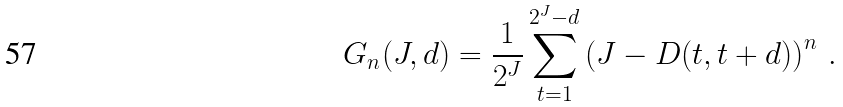<formula> <loc_0><loc_0><loc_500><loc_500>G _ { n } ( J , d ) = \frac { 1 } { 2 ^ { J } } \sum _ { t = 1 } ^ { 2 ^ { J } - d } \left ( J - D ( t , t + d ) \right ) ^ { n } \, .</formula> 